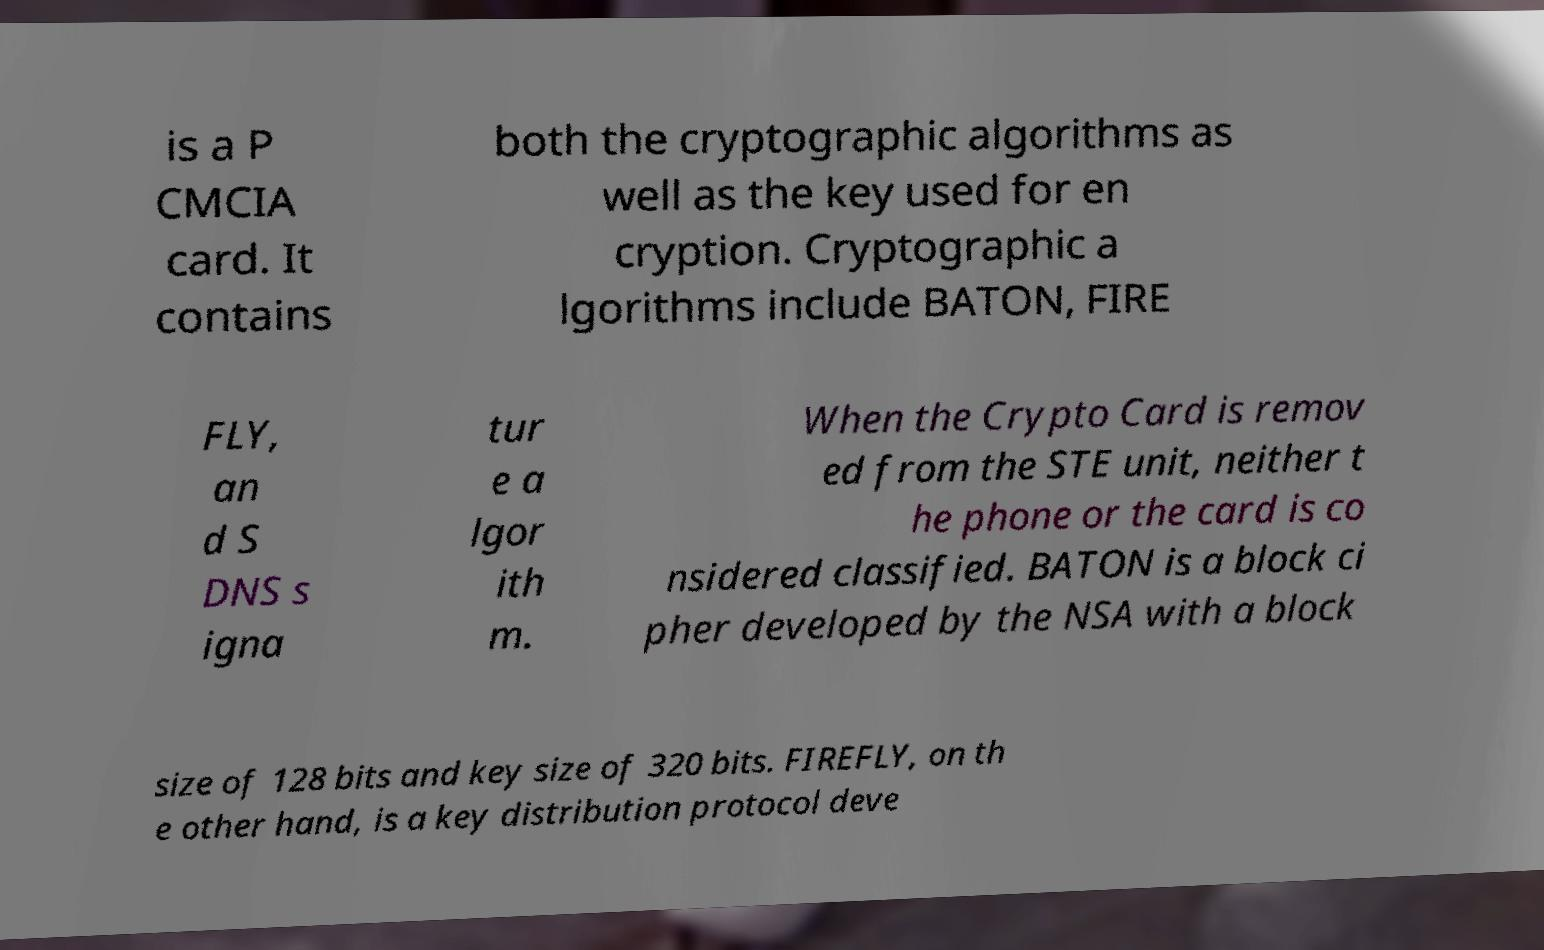What messages or text are displayed in this image? I need them in a readable, typed format. is a P CMCIA card. It contains both the cryptographic algorithms as well as the key used for en cryption. Cryptographic a lgorithms include BATON, FIRE FLY, an d S DNS s igna tur e a lgor ith m. When the Crypto Card is remov ed from the STE unit, neither t he phone or the card is co nsidered classified. BATON is a block ci pher developed by the NSA with a block size of 128 bits and key size of 320 bits. FIREFLY, on th e other hand, is a key distribution protocol deve 